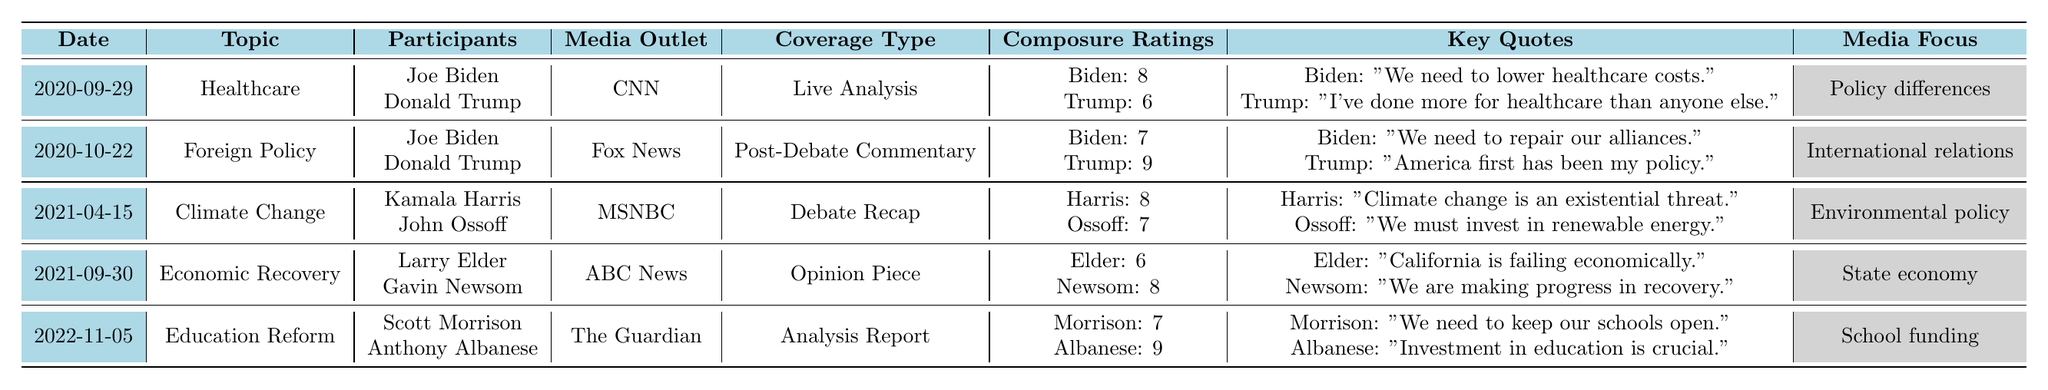What was the topic of the debate held on September 29, 2020? The table indicates that the debate date is September 29, 2020, and the associated topic for that date is "Healthcare."
Answer: Healthcare Which participant received a higher composure rating in the Foreign Policy debate? In the Foreign Policy debate on October 22, 2020, Joe Biden had a composure rating of 7, while Donald Trump had a higher rating of 9. Therefore, Trump received the higher rating.
Answer: Donald Trump What is the key quote from Kamala Harris during the Climate Change debate? The key quote from Kamala Harris in the Climate Change debate on April 15, 2021, is "Climate change is an existential threat."
Answer: "Climate change is an existential threat." Which media outlet covered the Education Reform debate? According to the table, the media outlet that covered the Education Reform debate on November 5, 2022, is "The Guardian."
Answer: The Guardian Calculate the average composure rating of the participants in the Economic Recovery debate. The composure ratings for the Economic Recovery debate are 6 for Larry Elder and 8 for Gavin Newsom. The sum is (6 + 8) = 14, and there are 2 participants, so the average is 14/2 = 7.
Answer: 7 Did the audience reaction for the Climate Change debate show support? The audience reaction for the Climate Change debate on April 15, 2021, is specified as "Supportive," which indicates a positive response. Therefore, the audience did show support.
Answer: Yes Which participant in the Education Reform debate had the lowest composure rating? In the Education Reform debate on November 5, 2022, Scott Morrison had a composure rating of 7, while Anthony Albanese had a rating of 9. Thus, Morrison had the lower rating.
Answer: Scott Morrison What was the key media focus in the Healthcare debate? The table indicates that the media focus during the Healthcare debate on September 29, 2020, was "Policy differences."
Answer: Policy differences Who had a more positive audience reaction in the Foreign Policy debate? The audience reaction for the Foreign Policy debate held on October 22, 2020, was "Positive for Trump," indicating that Trump's performance was better received compared to Biden's.
Answer: Donald Trump How many debates had a composure rating of 8 or higher? From the table, three debates had participants with ratings of 8 or higher: Healthcare (Biden: 8), Climate Change (Harris: 8), and Education Reform (Albanese: 9). Therefore, there are a total of 3.
Answer: 3 